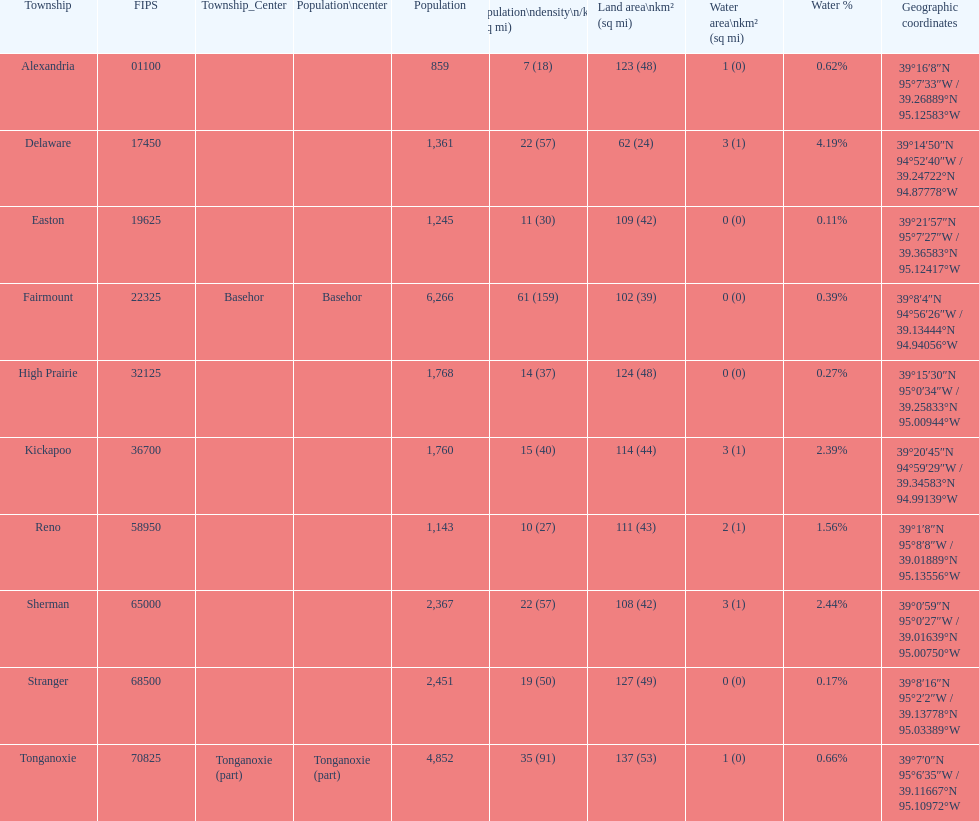How many townships are in leavenworth county? 10. 